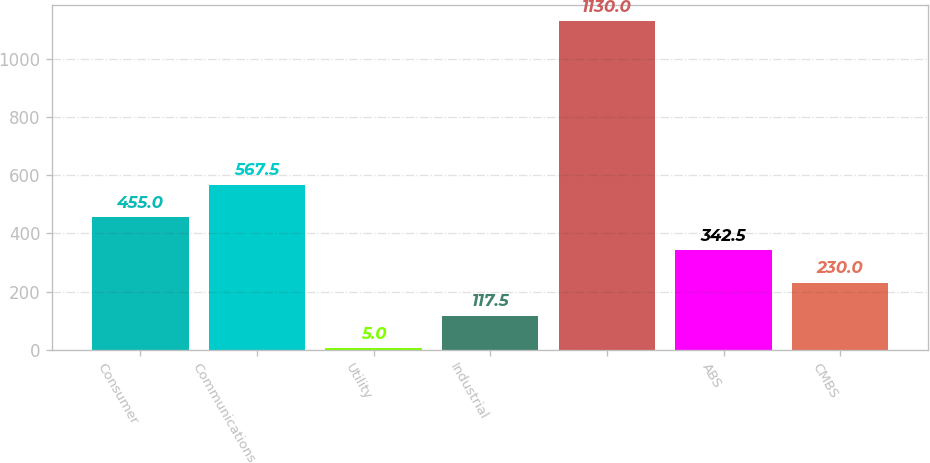Convert chart. <chart><loc_0><loc_0><loc_500><loc_500><bar_chart><fcel>Consumer<fcel>Communications<fcel>Utility<fcel>Industrial<fcel>Unnamed: 4<fcel>ABS<fcel>CMBS<nl><fcel>455<fcel>567.5<fcel>5<fcel>117.5<fcel>1130<fcel>342.5<fcel>230<nl></chart> 